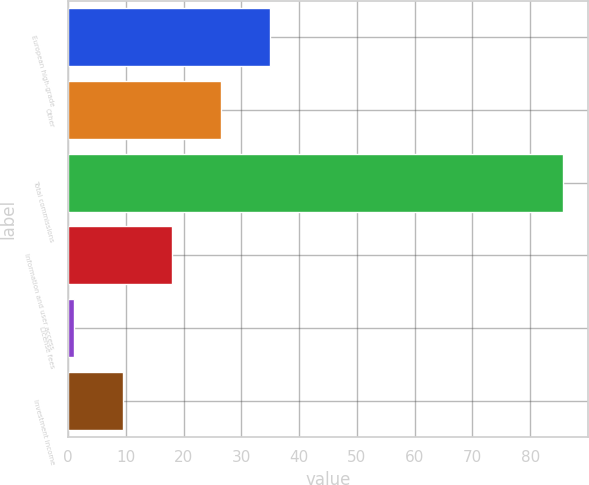<chart> <loc_0><loc_0><loc_500><loc_500><bar_chart><fcel>European high-grade<fcel>Other<fcel>Total commissions<fcel>Information and user access<fcel>License fees<fcel>Investment income<nl><fcel>34.88<fcel>26.41<fcel>85.7<fcel>17.94<fcel>1<fcel>9.47<nl></chart> 